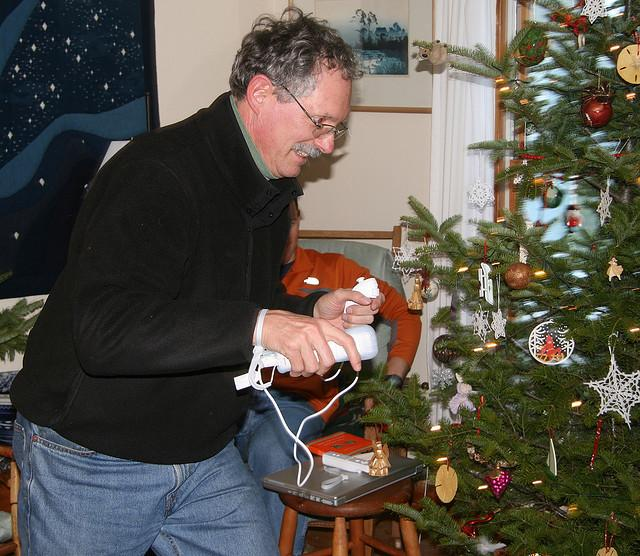What is the month depicted in the image? december 